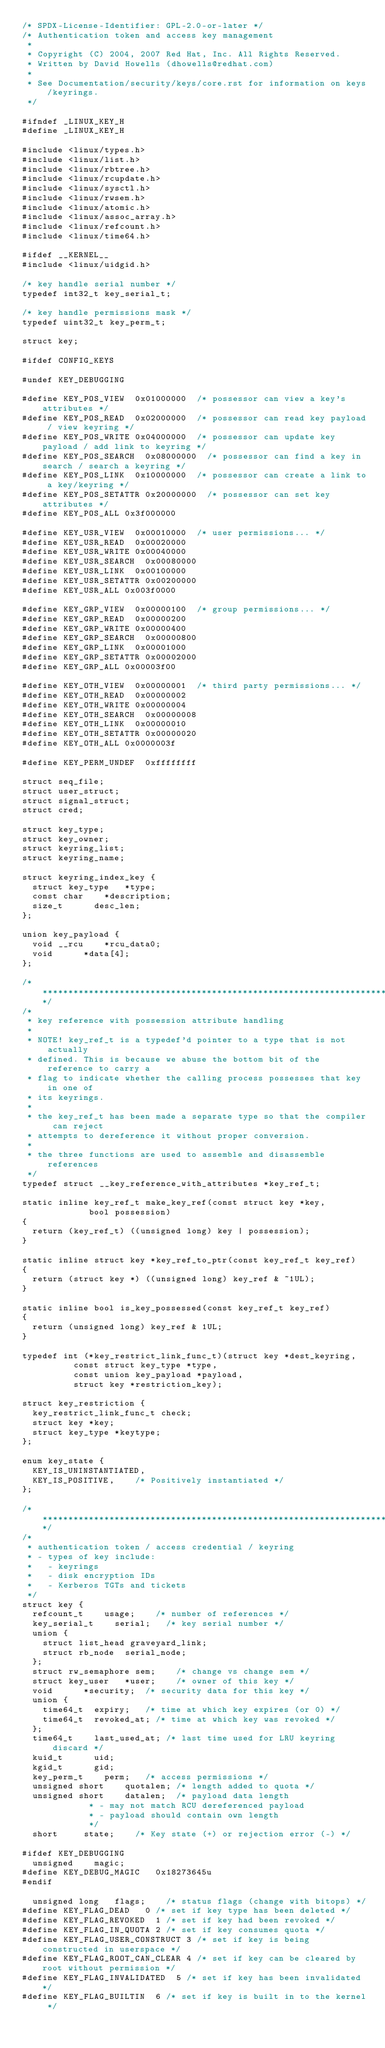Convert code to text. <code><loc_0><loc_0><loc_500><loc_500><_C_>/* SPDX-License-Identifier: GPL-2.0-or-later */
/* Authentication token and access key management
 *
 * Copyright (C) 2004, 2007 Red Hat, Inc. All Rights Reserved.
 * Written by David Howells (dhowells@redhat.com)
 *
 * See Documentation/security/keys/core.rst for information on keys/keyrings.
 */

#ifndef _LINUX_KEY_H
#define _LINUX_KEY_H

#include <linux/types.h>
#include <linux/list.h>
#include <linux/rbtree.h>
#include <linux/rcupdate.h>
#include <linux/sysctl.h>
#include <linux/rwsem.h>
#include <linux/atomic.h>
#include <linux/assoc_array.h>
#include <linux/refcount.h>
#include <linux/time64.h>

#ifdef __KERNEL__
#include <linux/uidgid.h>

/* key handle serial number */
typedef int32_t key_serial_t;

/* key handle permissions mask */
typedef uint32_t key_perm_t;

struct key;

#ifdef CONFIG_KEYS

#undef KEY_DEBUGGING

#define KEY_POS_VIEW	0x01000000	/* possessor can view a key's attributes */
#define KEY_POS_READ	0x02000000	/* possessor can read key payload / view keyring */
#define KEY_POS_WRITE	0x04000000	/* possessor can update key payload / add link to keyring */
#define KEY_POS_SEARCH	0x08000000	/* possessor can find a key in search / search a keyring */
#define KEY_POS_LINK	0x10000000	/* possessor can create a link to a key/keyring */
#define KEY_POS_SETATTR	0x20000000	/* possessor can set key attributes */
#define KEY_POS_ALL	0x3f000000

#define KEY_USR_VIEW	0x00010000	/* user permissions... */
#define KEY_USR_READ	0x00020000
#define KEY_USR_WRITE	0x00040000
#define KEY_USR_SEARCH	0x00080000
#define KEY_USR_LINK	0x00100000
#define KEY_USR_SETATTR	0x00200000
#define KEY_USR_ALL	0x003f0000

#define KEY_GRP_VIEW	0x00000100	/* group permissions... */
#define KEY_GRP_READ	0x00000200
#define KEY_GRP_WRITE	0x00000400
#define KEY_GRP_SEARCH	0x00000800
#define KEY_GRP_LINK	0x00001000
#define KEY_GRP_SETATTR	0x00002000
#define KEY_GRP_ALL	0x00003f00

#define KEY_OTH_VIEW	0x00000001	/* third party permissions... */
#define KEY_OTH_READ	0x00000002
#define KEY_OTH_WRITE	0x00000004
#define KEY_OTH_SEARCH	0x00000008
#define KEY_OTH_LINK	0x00000010
#define KEY_OTH_SETATTR	0x00000020
#define KEY_OTH_ALL	0x0000003f

#define KEY_PERM_UNDEF	0xffffffff

struct seq_file;
struct user_struct;
struct signal_struct;
struct cred;

struct key_type;
struct key_owner;
struct keyring_list;
struct keyring_name;

struct keyring_index_key {
	struct key_type		*type;
	const char		*description;
	size_t			desc_len;
};

union key_payload {
	void __rcu		*rcu_data0;
	void			*data[4];
};

/*****************************************************************************/
/*
 * key reference with possession attribute handling
 *
 * NOTE! key_ref_t is a typedef'd pointer to a type that is not actually
 * defined. This is because we abuse the bottom bit of the reference to carry a
 * flag to indicate whether the calling process possesses that key in one of
 * its keyrings.
 *
 * the key_ref_t has been made a separate type so that the compiler can reject
 * attempts to dereference it without proper conversion.
 *
 * the three functions are used to assemble and disassemble references
 */
typedef struct __key_reference_with_attributes *key_ref_t;

static inline key_ref_t make_key_ref(const struct key *key,
				     bool possession)
{
	return (key_ref_t) ((unsigned long) key | possession);
}

static inline struct key *key_ref_to_ptr(const key_ref_t key_ref)
{
	return (struct key *) ((unsigned long) key_ref & ~1UL);
}

static inline bool is_key_possessed(const key_ref_t key_ref)
{
	return (unsigned long) key_ref & 1UL;
}

typedef int (*key_restrict_link_func_t)(struct key *dest_keyring,
					const struct key_type *type,
					const union key_payload *payload,
					struct key *restriction_key);

struct key_restriction {
	key_restrict_link_func_t check;
	struct key *key;
	struct key_type *keytype;
};

enum key_state {
	KEY_IS_UNINSTANTIATED,
	KEY_IS_POSITIVE,		/* Positively instantiated */
};

/*****************************************************************************/
/*
 * authentication token / access credential / keyring
 * - types of key include:
 *   - keyrings
 *   - disk encryption IDs
 *   - Kerberos TGTs and tickets
 */
struct key {
	refcount_t		usage;		/* number of references */
	key_serial_t		serial;		/* key serial number */
	union {
		struct list_head graveyard_link;
		struct rb_node	serial_node;
	};
	struct rw_semaphore	sem;		/* change vs change sem */
	struct key_user		*user;		/* owner of this key */
	void			*security;	/* security data for this key */
	union {
		time64_t	expiry;		/* time at which key expires (or 0) */
		time64_t	revoked_at;	/* time at which key was revoked */
	};
	time64_t		last_used_at;	/* last time used for LRU keyring discard */
	kuid_t			uid;
	kgid_t			gid;
	key_perm_t		perm;		/* access permissions */
	unsigned short		quotalen;	/* length added to quota */
	unsigned short		datalen;	/* payload data length
						 * - may not match RCU dereferenced payload
						 * - payload should contain own length
						 */
	short			state;		/* Key state (+) or rejection error (-) */

#ifdef KEY_DEBUGGING
	unsigned		magic;
#define KEY_DEBUG_MAGIC		0x18273645u
#endif

	unsigned long		flags;		/* status flags (change with bitops) */
#define KEY_FLAG_DEAD		0	/* set if key type has been deleted */
#define KEY_FLAG_REVOKED	1	/* set if key had been revoked */
#define KEY_FLAG_IN_QUOTA	2	/* set if key consumes quota */
#define KEY_FLAG_USER_CONSTRUCT	3	/* set if key is being constructed in userspace */
#define KEY_FLAG_ROOT_CAN_CLEAR	4	/* set if key can be cleared by root without permission */
#define KEY_FLAG_INVALIDATED	5	/* set if key has been invalidated */
#define KEY_FLAG_BUILTIN	6	/* set if key is built in to the kernel */</code> 